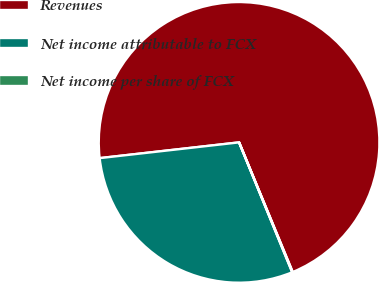Convert chart to OTSL. <chart><loc_0><loc_0><loc_500><loc_500><pie_chart><fcel>Revenues<fcel>Net income attributable to FCX<fcel>Net income per share of FCX<nl><fcel>70.55%<fcel>29.39%<fcel>0.06%<nl></chart> 